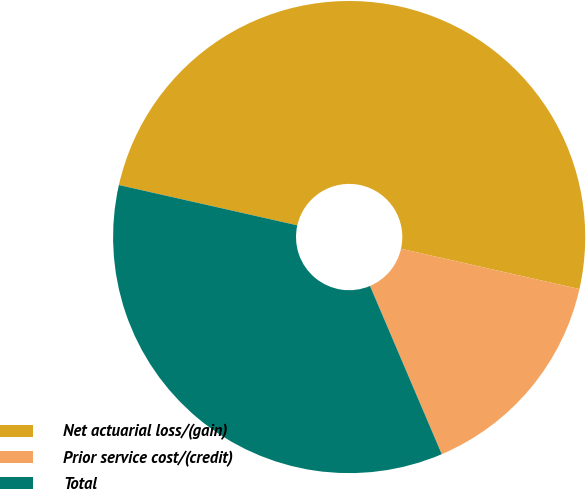Convert chart. <chart><loc_0><loc_0><loc_500><loc_500><pie_chart><fcel>Net actuarial loss/(gain)<fcel>Prior service cost/(credit)<fcel>Total<nl><fcel>50.0%<fcel>15.05%<fcel>34.95%<nl></chart> 